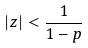<formula> <loc_0><loc_0><loc_500><loc_500>| z | < \frac { 1 } { 1 - p }</formula> 